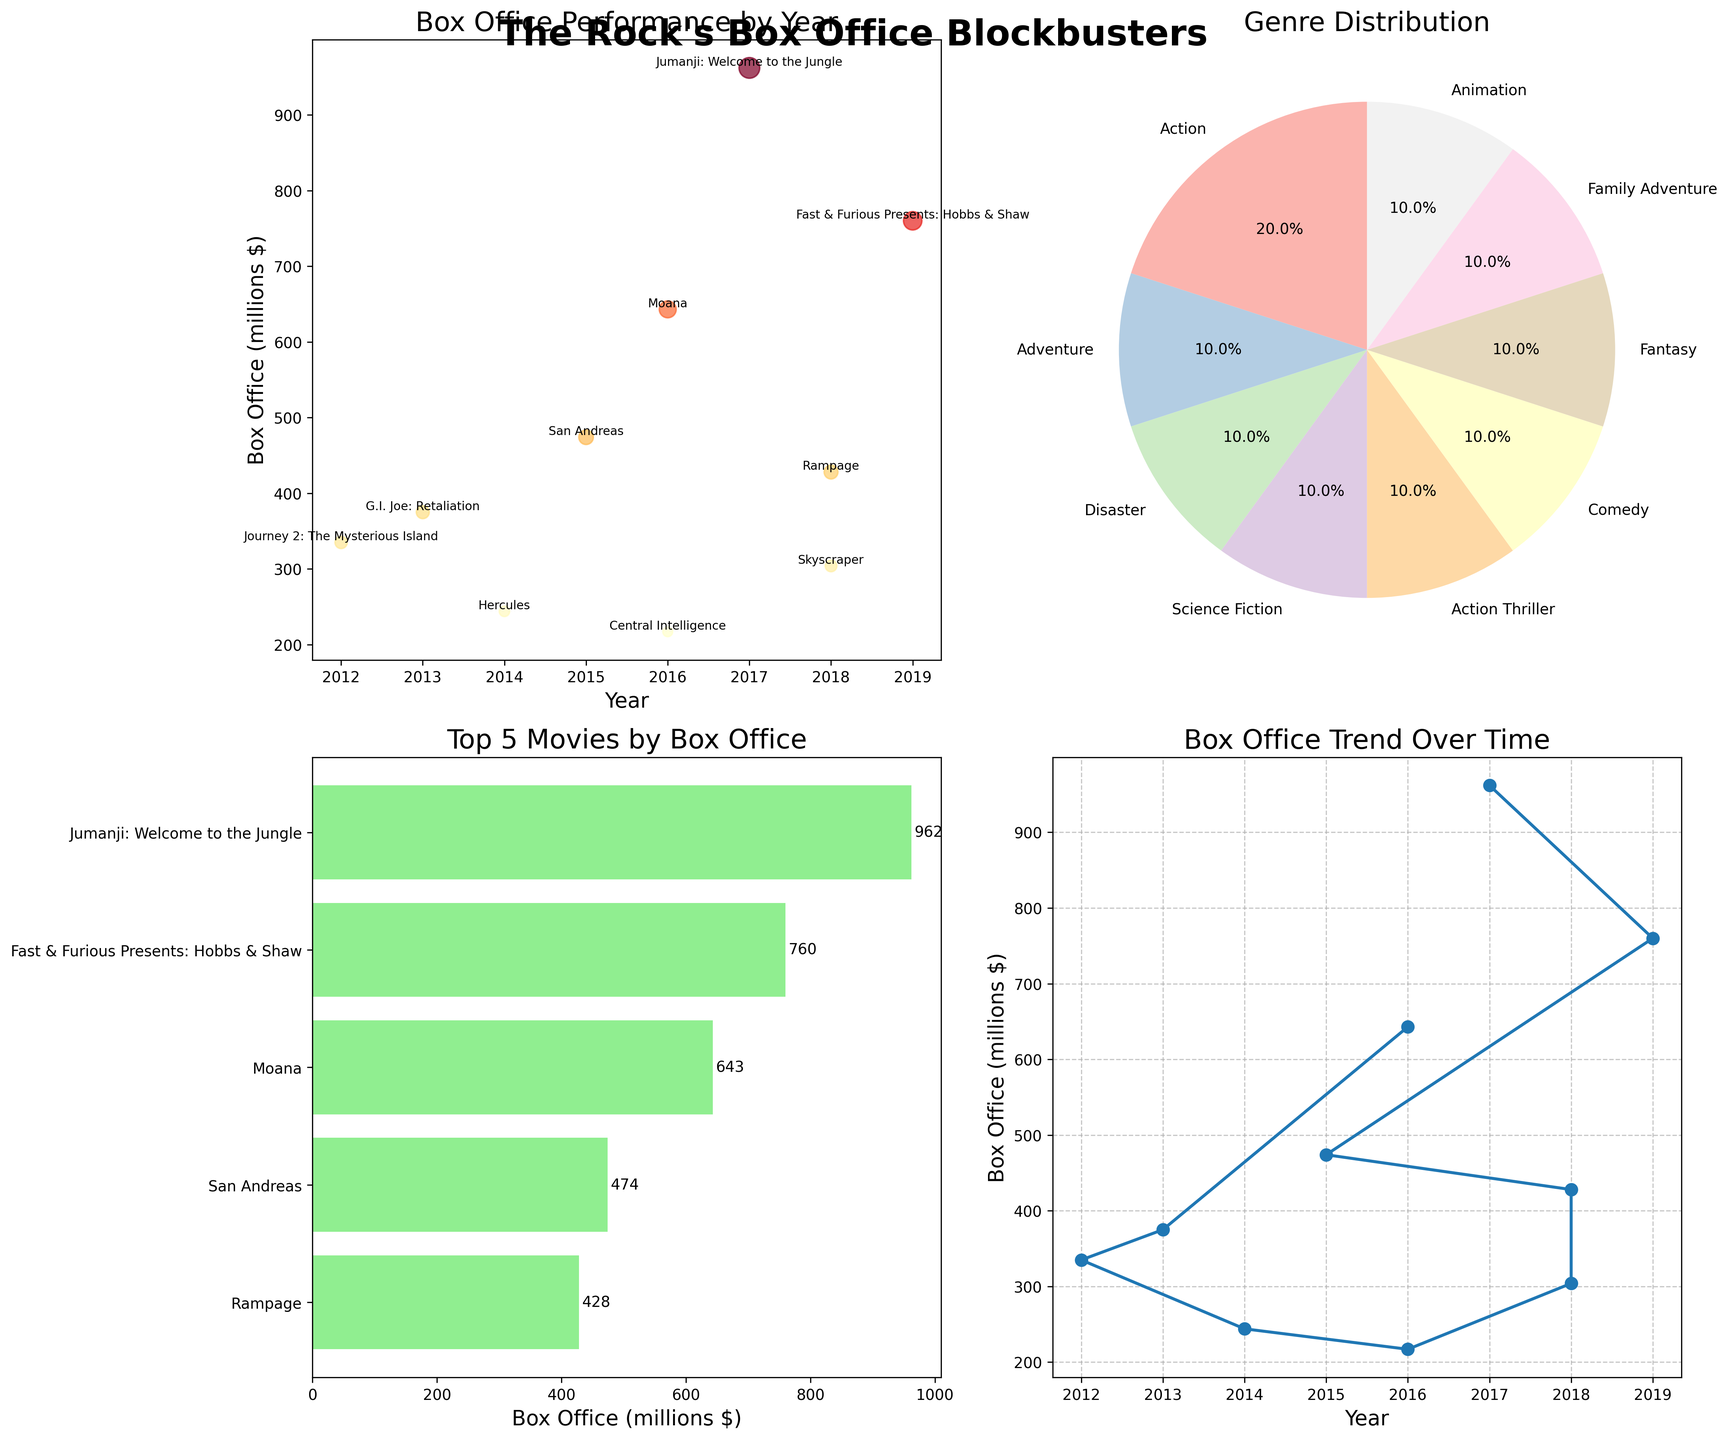What is the title of Subplot 1? The title of Subplot 1 can be found at the top of the plot. It shows the heading that describes what the plot is about.
Answer: Box Office Performance by Year How many genres are represented in Subplot 2? By inspecting Subplot 2, you can count the number of segments in the pie chart, which represent different genres.
Answer: 7 Which movie had the highest box office performance, and what was its value? To determine this, look at Subplot 3 where the top 5 movies by box office are displayed in a bar chart. The top movie is at the top of the chart.
Answer: Jumanji: Welcome to the Jungle, 962 million Which genre has the highest percentage in Subplot 2? Check the largest segment of the pie chart in Subplot 2 and read its label.
Answer: Action When did "Moana" release, and what was its box office performance? Look for "Moana" in any of the subplots where individual movies' performances are annotated. In Subplot 1, the year and box office performance are shown beside the movie name.
Answer: 2016, 643 million How does the trend line in Subplot 4 depict the box office performance over time? By following the trend line in Subplot 4, observe the points from left (earliest year) to right (most recent year) to see the overall direction.
Answer: Increasing What percentage of The Rock's top 10 movies fall under the action genre according to Subplot 2? Identify the "Action" segment in the pie chart of Subplot 2 and read the percentage label.
Answer: 30% Which movie had the lowest box office performance and what was its value? In Subplot 3, the movie with the smallest bar represents the lowest box office performance among the top movies.
Answer: Central Intelligence, 217 million Compare the box office performances of "San Andreas" and "Rampage". Look at the annotated data points in Subplot 1 or the trend in Subplot 4 for the specific box office values of both movies and compare them.
Answer: San Andreas: 474 million, Rampage: 428 million How many of The Rock's movies listed released before 2015? Count the data points in Subplot 1 that are positioned on the years before 2015.
Answer: 3 